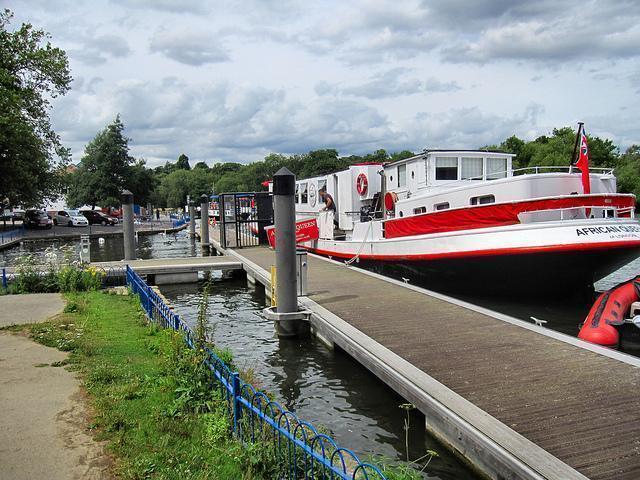What's the term for how this boat is parked?
Select the accurate answer and provide explanation: 'Answer: answer
Rationale: rationale.'
Options: Docked, waiting, anchored, setting. Answer: docked.
Rationale: The term is docked. 